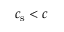Convert formula to latex. <formula><loc_0><loc_0><loc_500><loc_500>c _ { s } < c</formula> 